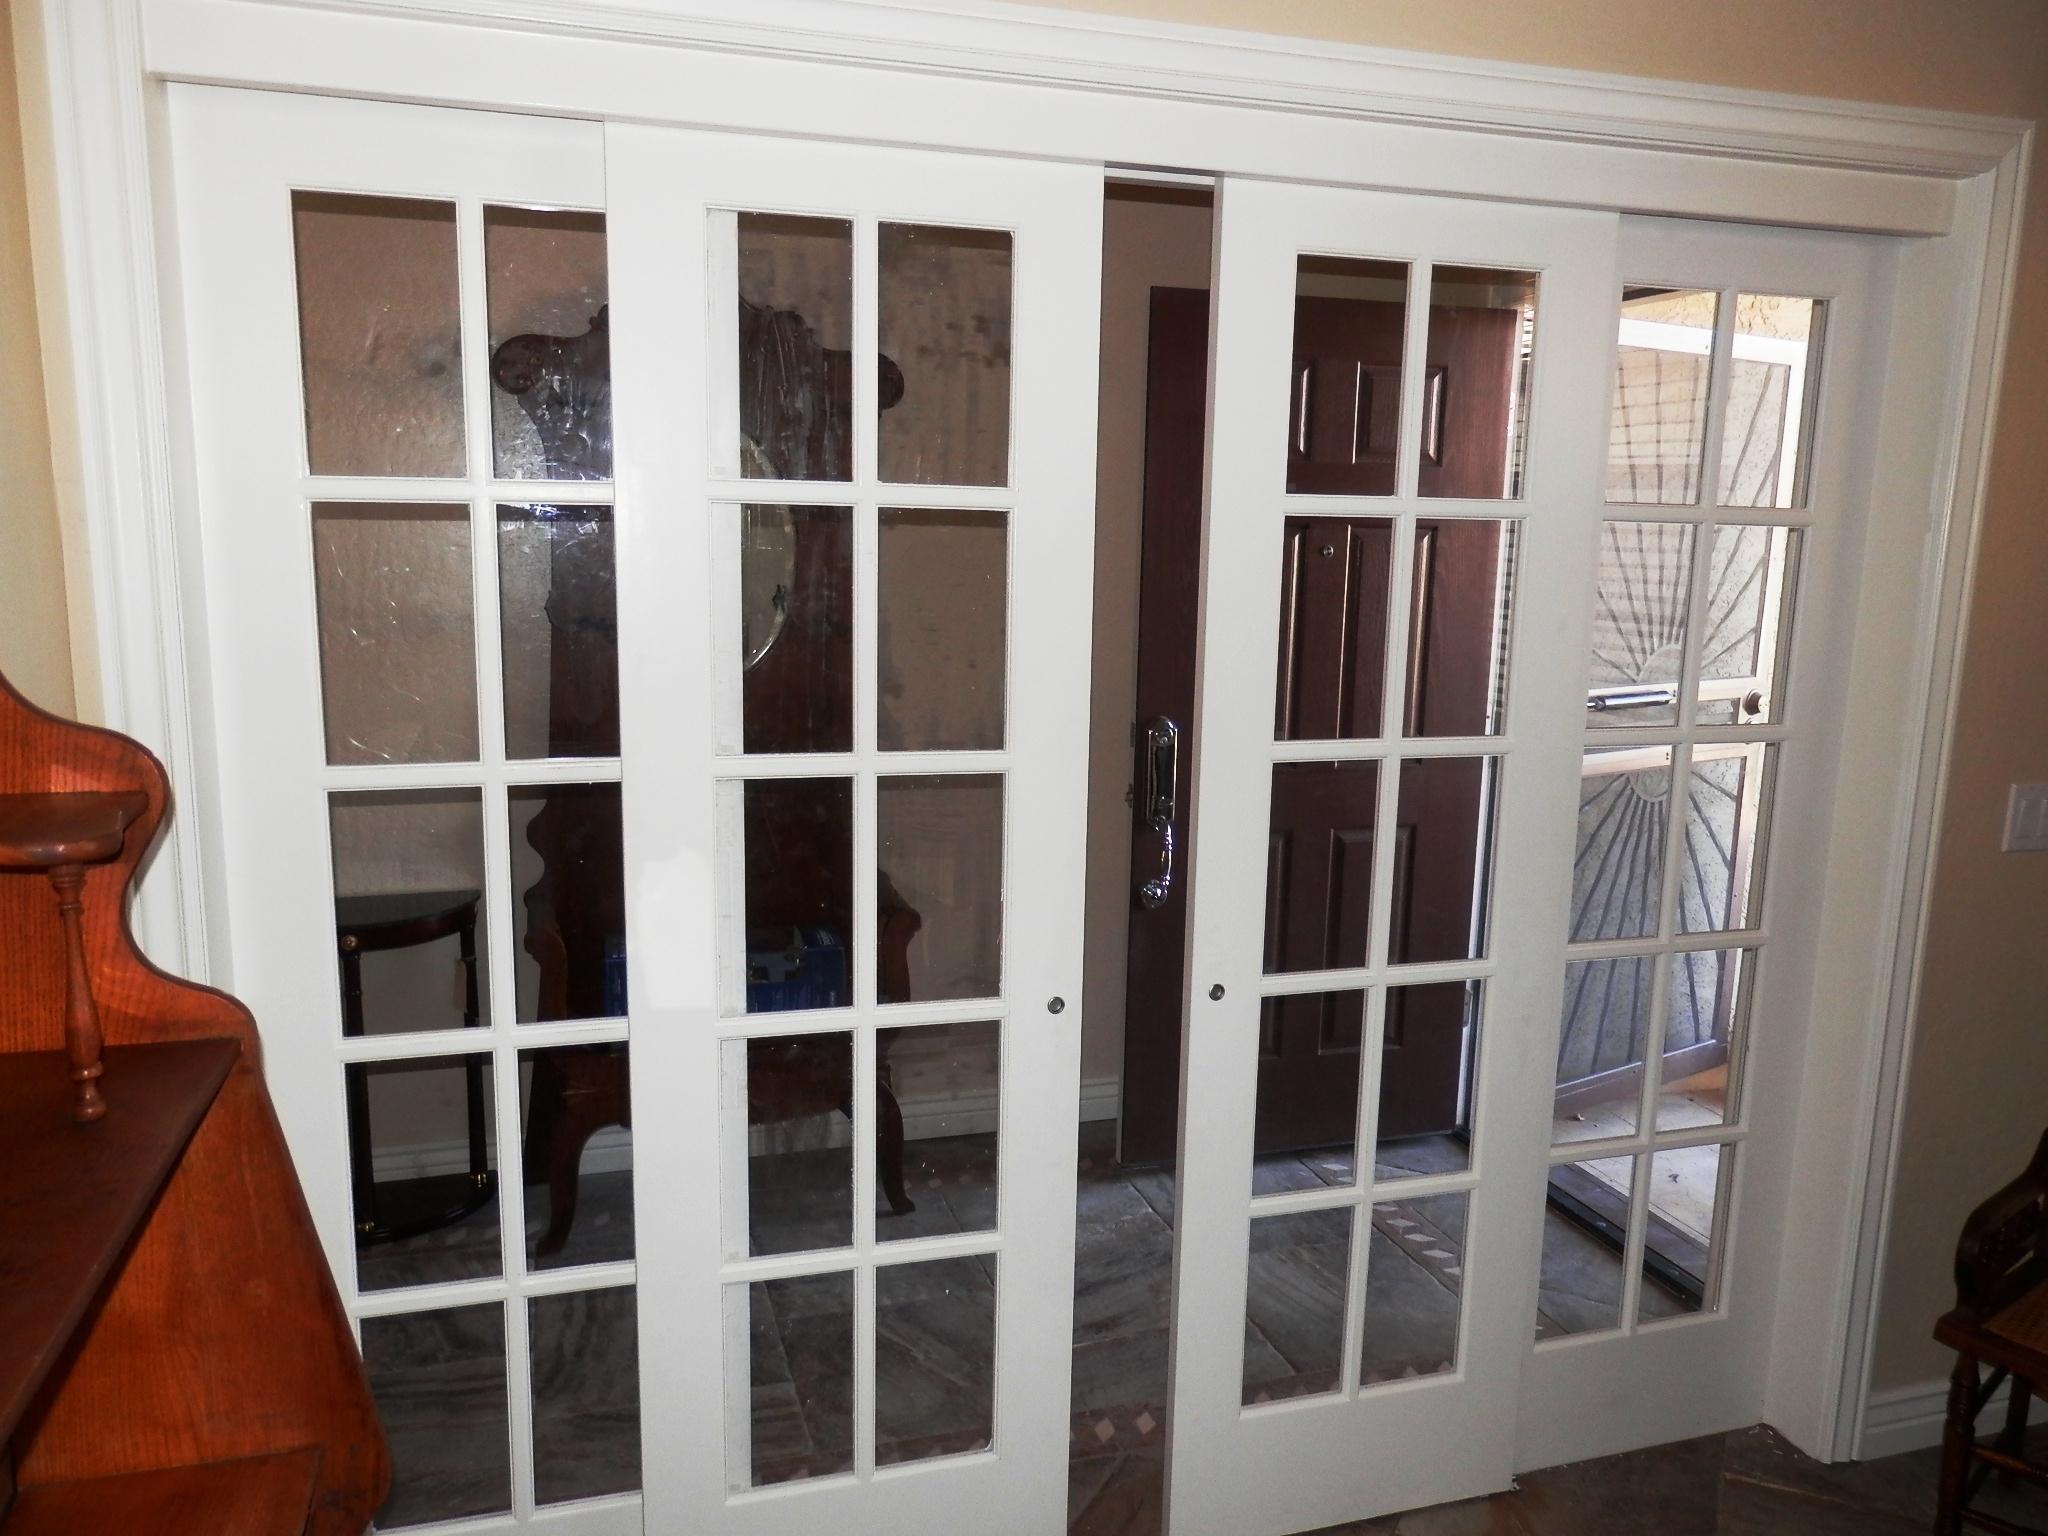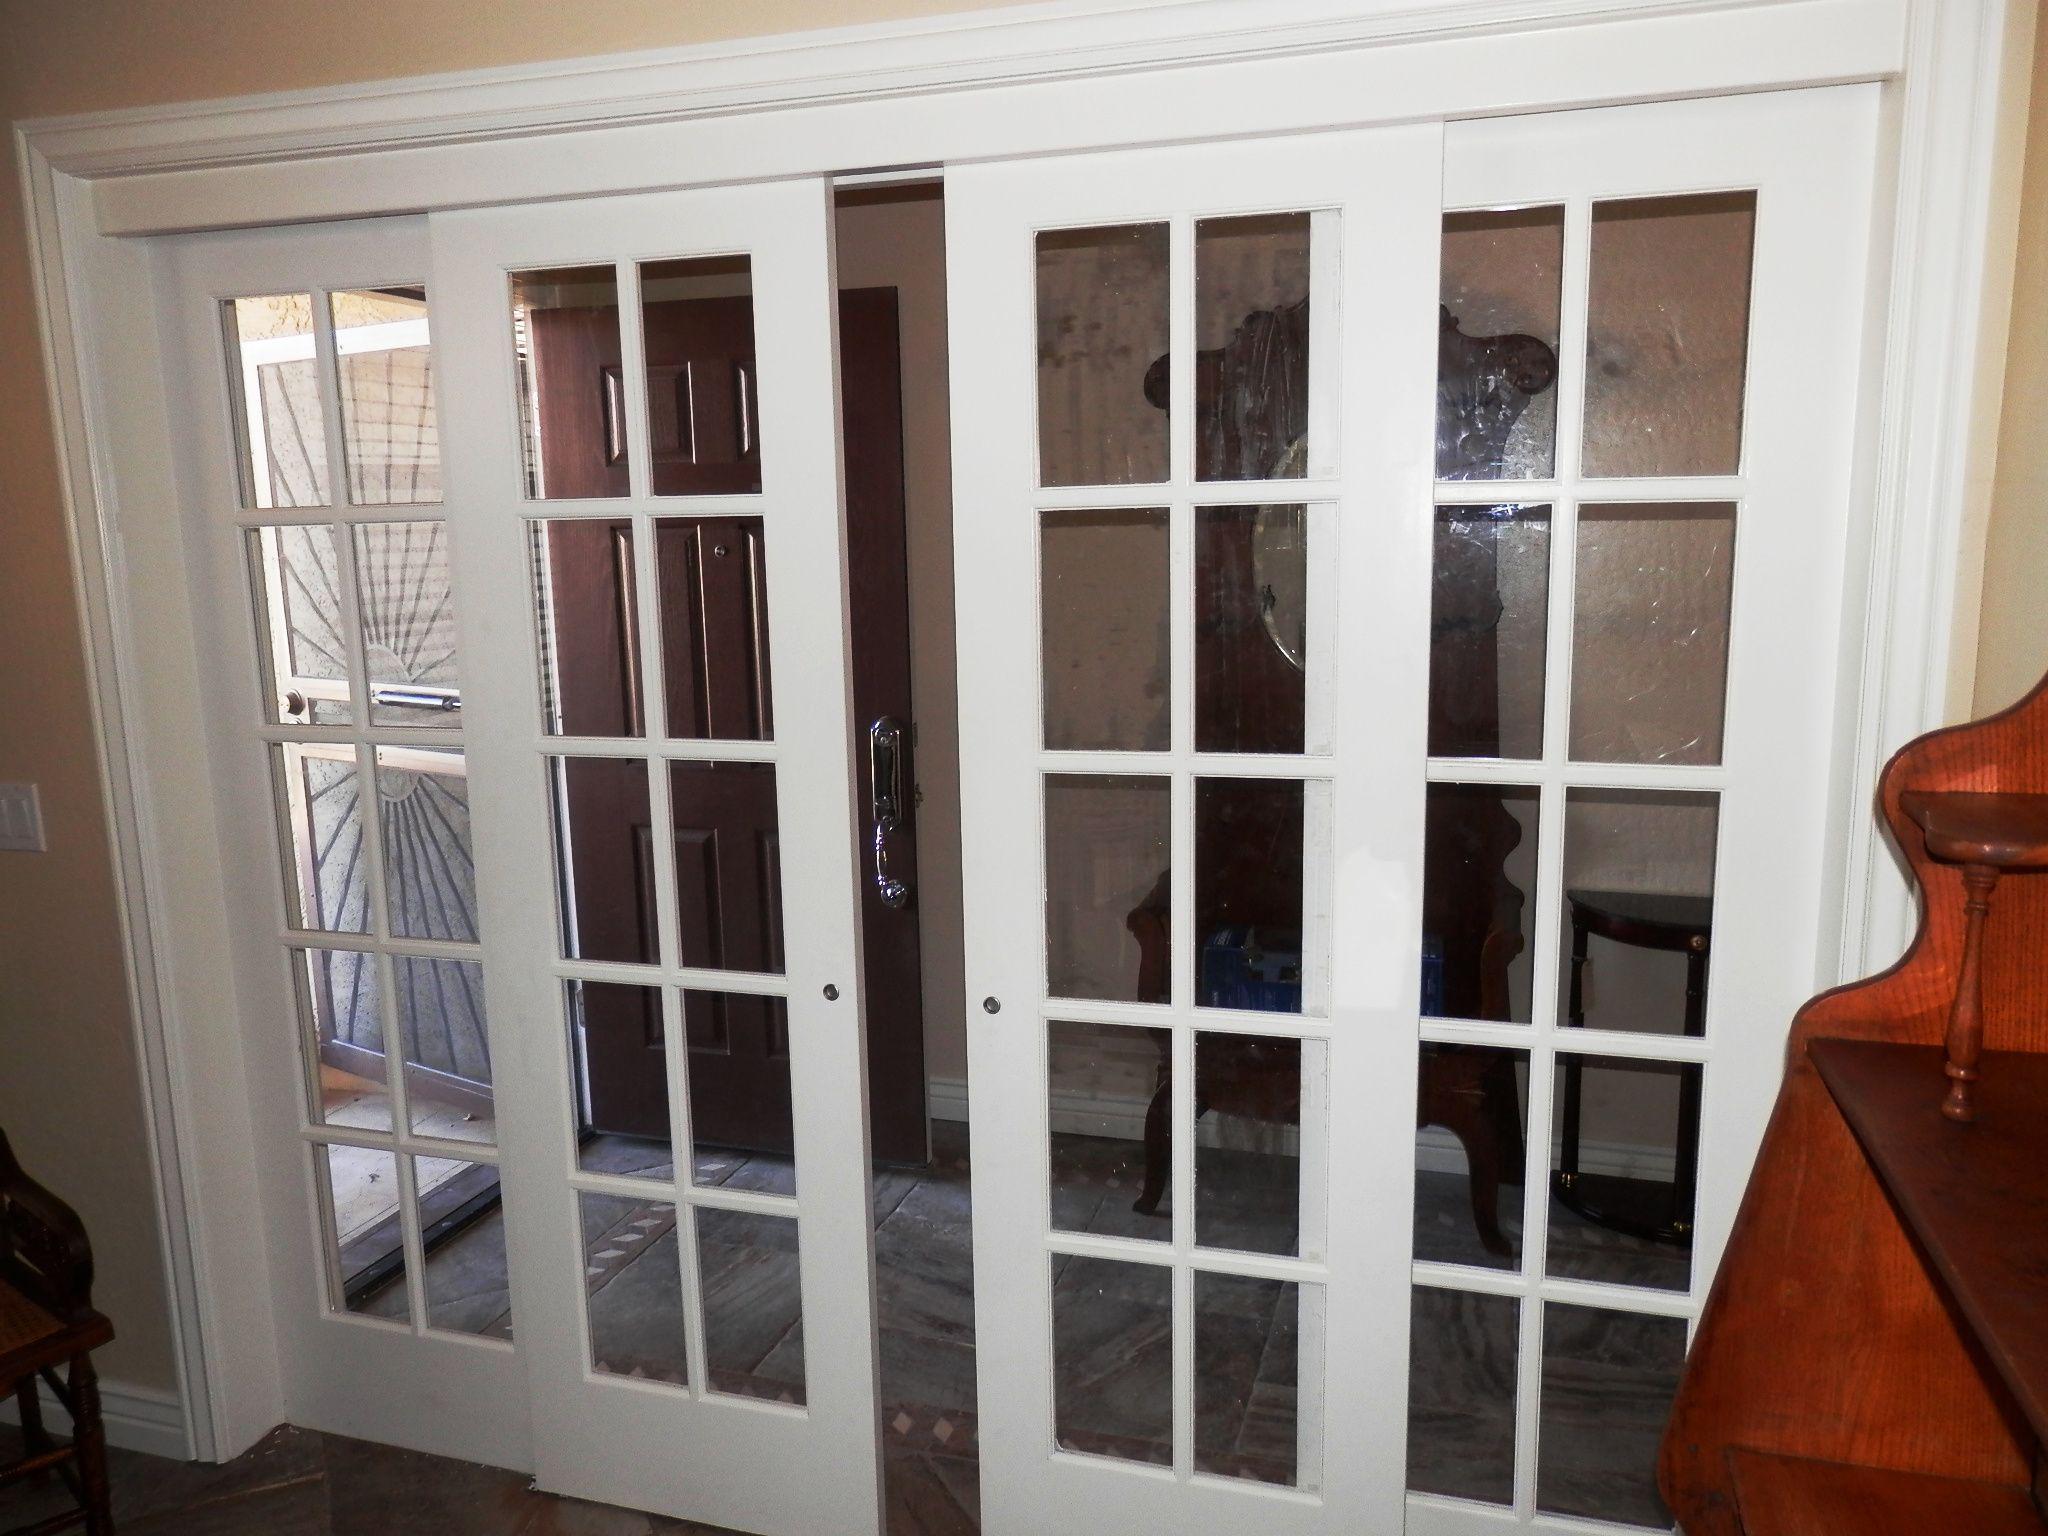The first image is the image on the left, the second image is the image on the right. For the images shown, is this caption "Both doors have less than a 12 inch opening." true? Answer yes or no. Yes. The first image is the image on the left, the second image is the image on the right. Considering the images on both sides, is "An image shows a door open wide enough to walk through." valid? Answer yes or no. No. 